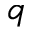<formula> <loc_0><loc_0><loc_500><loc_500>q</formula> 